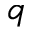<formula> <loc_0><loc_0><loc_500><loc_500>q</formula> 